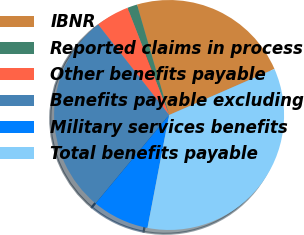Convert chart. <chart><loc_0><loc_0><loc_500><loc_500><pie_chart><fcel>IBNR<fcel>Reported claims in process<fcel>Other benefits payable<fcel>Benefits payable excluding<fcel>Military services benefits<fcel>Total benefits payable<nl><fcel>22.95%<fcel>1.38%<fcel>4.7%<fcel>28.38%<fcel>8.02%<fcel>34.57%<nl></chart> 